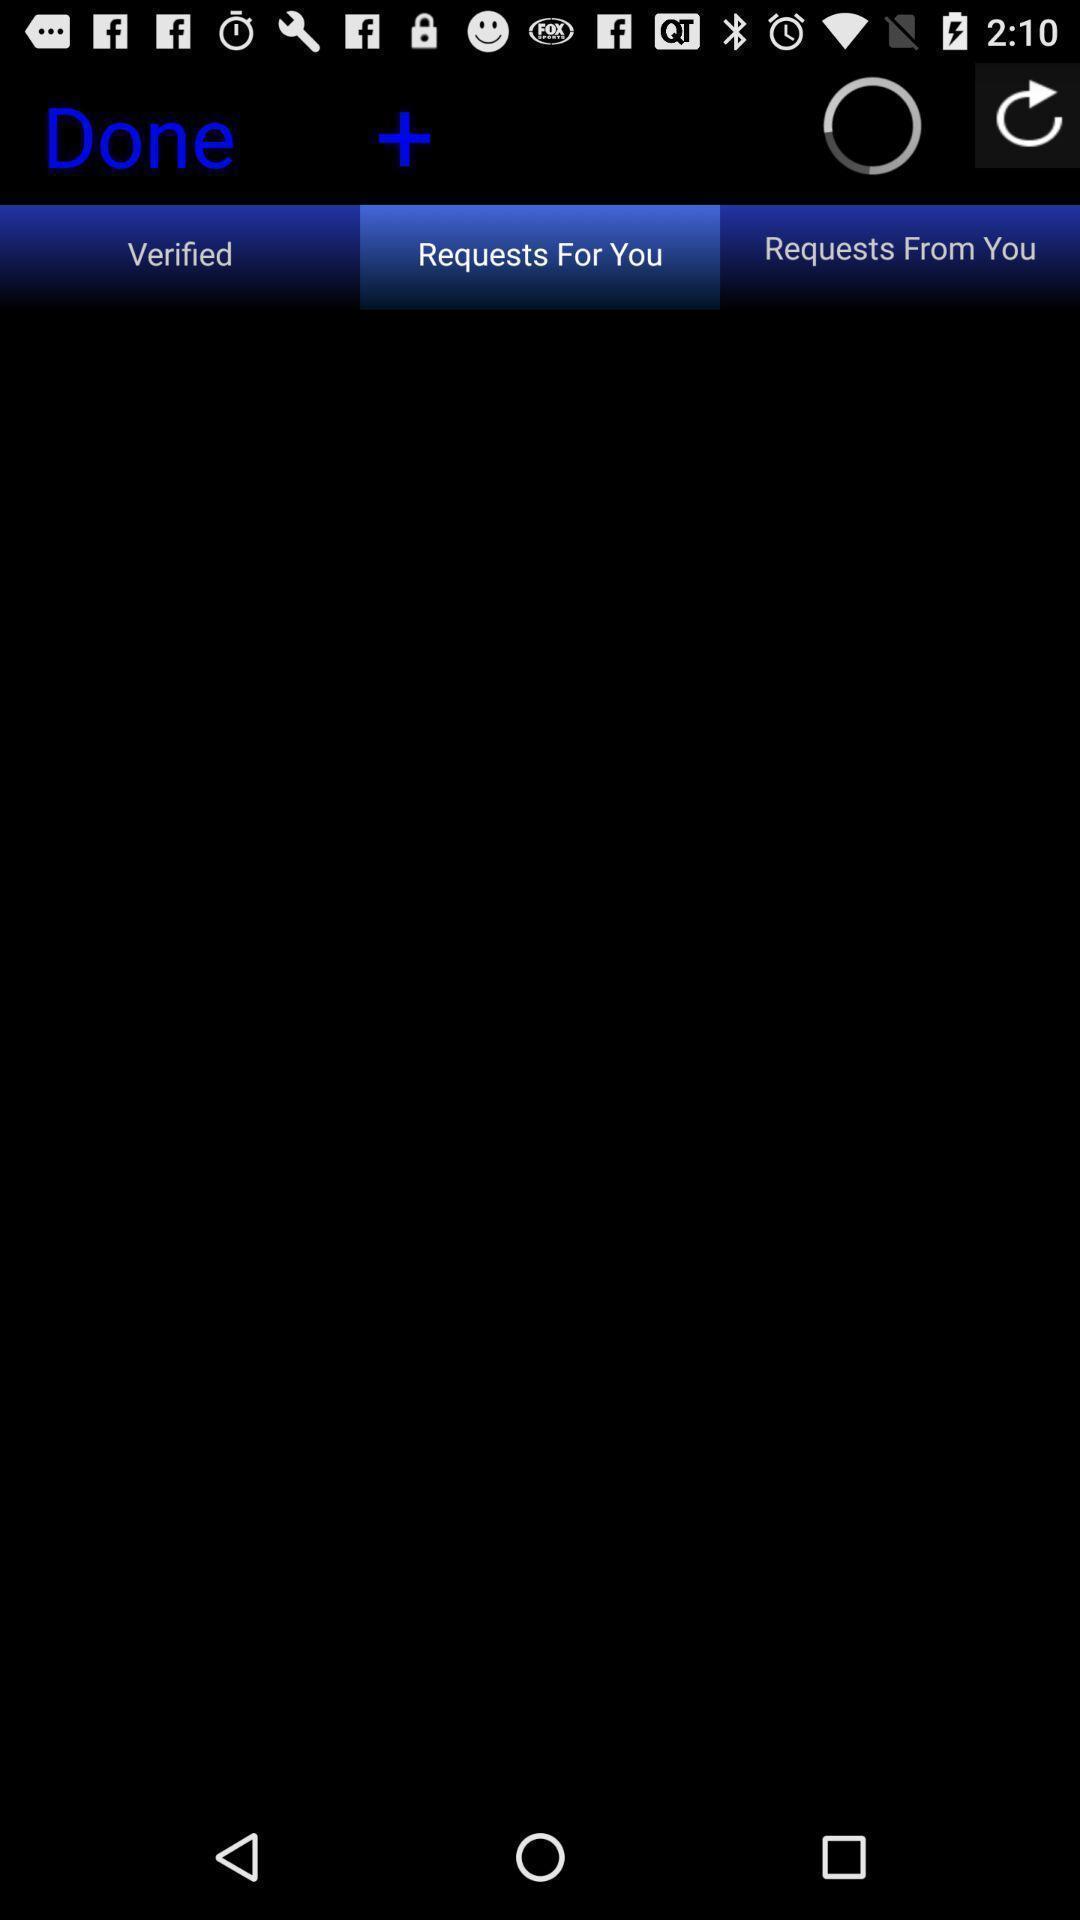What can you discern from this picture? Screen showing requests for connecting people. 